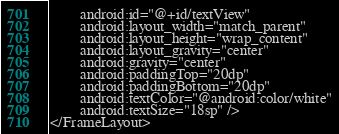Convert code to text. <code><loc_0><loc_0><loc_500><loc_500><_XML_>        android:id="@+id/textView"
        android:layout_width="match_parent"
        android:layout_height="wrap_content"
        android:layout_gravity="center"
        android:gravity="center"
        android:paddingTop="20dp"
        android:paddingBottom="20dp"
        android:textColor="@android:color/white"
        android:textSize="18sp" />
</FrameLayout></code> 